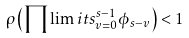Convert formula to latex. <formula><loc_0><loc_0><loc_500><loc_500>\rho \left ( \prod \lim i t s _ { v = 0 } ^ { s - 1 } \phi _ { s - v } \right ) < 1</formula> 